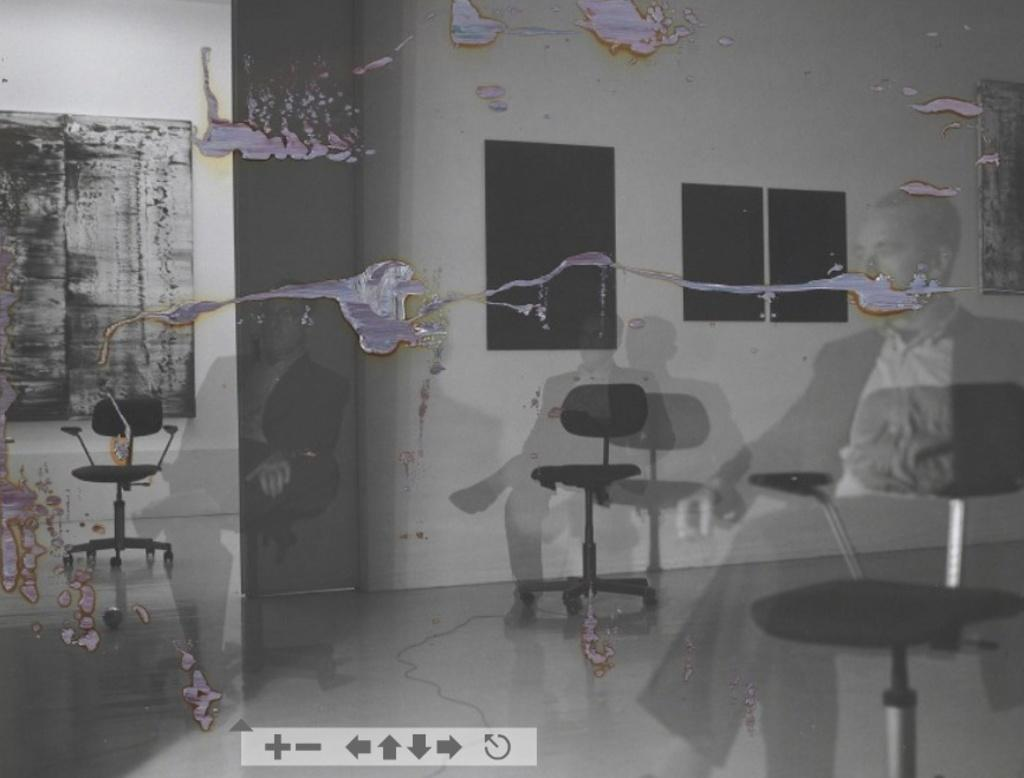What can be inferred about the image based on the provided facts? The image appears to be edited and shows reflections of persons sitting on chairs. What can be seen in the reflections of the persons in the image? The reflections suggest that the persons are sitting on chairs. What type of furniture is present in the image? There are chairs in the image. What else can be seen in the image besides the chairs and persons? There is a wall and other items in the image. What type of wool can be seen in the image? There is no wool present in the image. Is the queen visible in the image? There is no queen present in the image. 